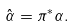Convert formula to latex. <formula><loc_0><loc_0><loc_500><loc_500>\hat { \alpha } = \pi ^ { * } \alpha .</formula> 